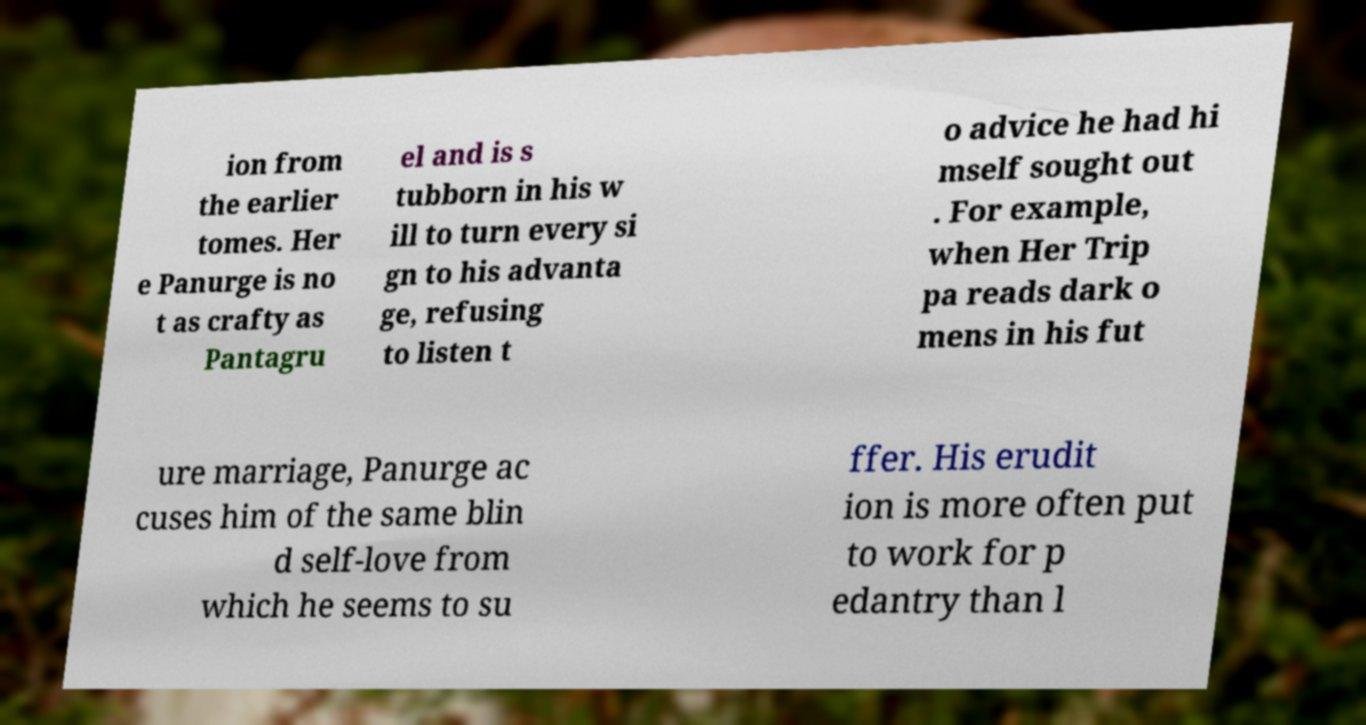There's text embedded in this image that I need extracted. Can you transcribe it verbatim? ion from the earlier tomes. Her e Panurge is no t as crafty as Pantagru el and is s tubborn in his w ill to turn every si gn to his advanta ge, refusing to listen t o advice he had hi mself sought out . For example, when Her Trip pa reads dark o mens in his fut ure marriage, Panurge ac cuses him of the same blin d self-love from which he seems to su ffer. His erudit ion is more often put to work for p edantry than l 